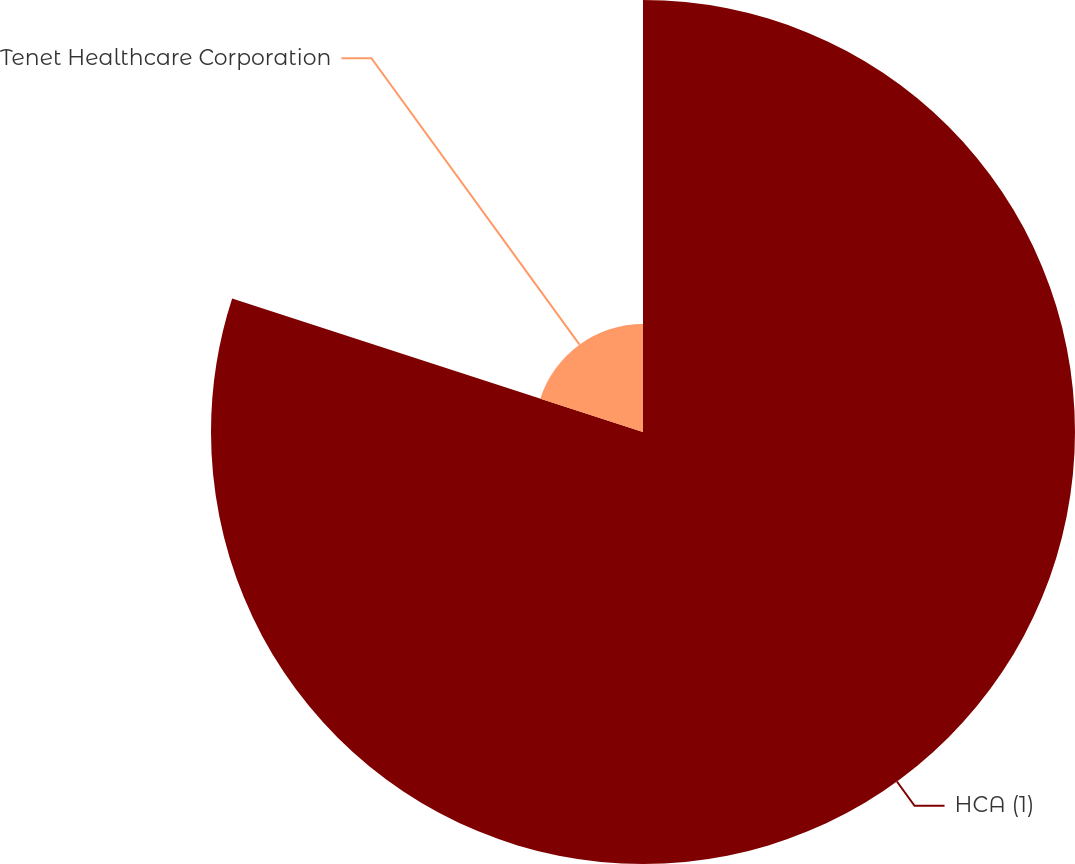Convert chart to OTSL. <chart><loc_0><loc_0><loc_500><loc_500><pie_chart><fcel>HCA (1)<fcel>Tenet Healthcare Corporation<nl><fcel>80.0%<fcel>20.0%<nl></chart> 